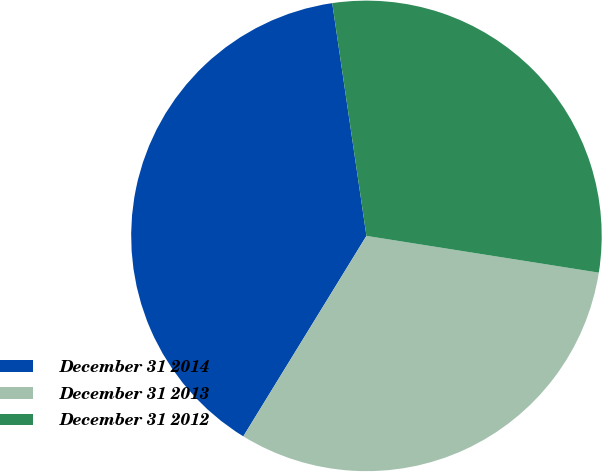Convert chart. <chart><loc_0><loc_0><loc_500><loc_500><pie_chart><fcel>December 31 2014<fcel>December 31 2013<fcel>December 31 2012<nl><fcel>38.91%<fcel>31.27%<fcel>29.82%<nl></chart> 